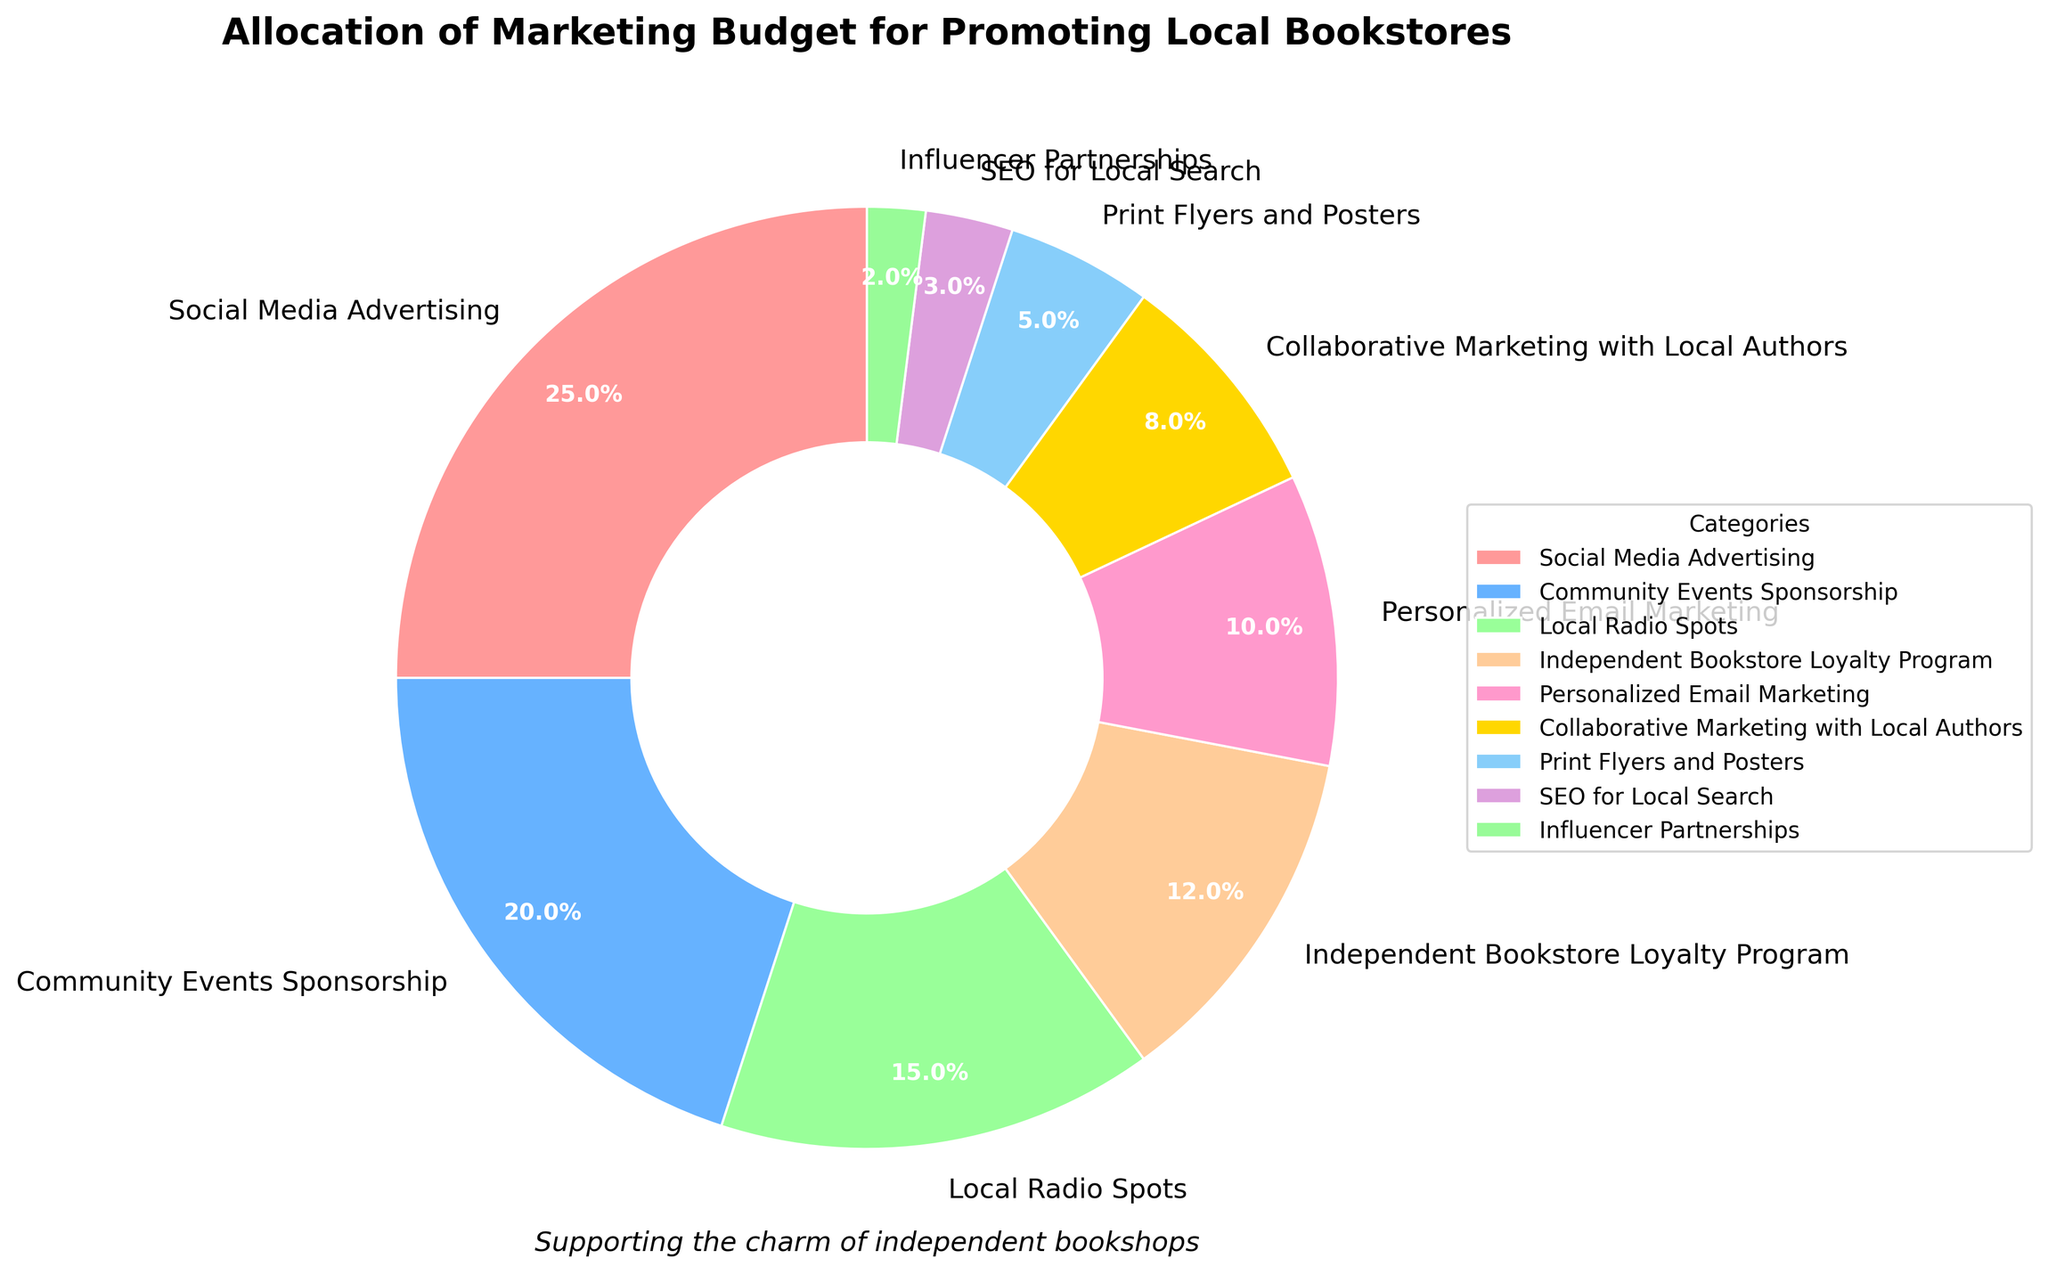What is the category with the highest percentage in the marketing budget? The category with the highest percentage is Social Media Advertising which is allocated 25% of the marketing budget.
Answer: Social Media Advertising What is the combined percentage of Community Events Sponsorship and Local Radio Spots? Add the percentages of Community Events Sponsorship (20%) and Local Radio Spots (15%): 20% + 15% = 35%.
Answer: 35% Which category has a smaller allocation than Independent Bookstore Loyalty Program but larger than SEO for Local Search? Independent Bookstore Loyalty Program has 12% and SEO for Local Search has 3%. The category with an allocation between 3% and 12% is Personalized Email Marketing with 10%.
Answer: Personalized Email Marketing What is the percent difference between Social Media Advertising and the lowest allocated category? Social Media Advertising has 25%, and Influencer Partnerships has the lowest percentage at 2%. The percent difference is 25% - 2% = 23%.
Answer: 23% What is the average percentage allocated to Collaborative Marketing with Local Authors, Print Flyers and Posters, and Influencer Partnerships? Add the percentages: 8% (Collaborative Marketing) + 5% (Print Flyers) + 2% (Influencer Partnerships) = 15%. Then, divide by 3: 15% / 3 = 5%.
Answer: 5% Which categories together make up exactly 50% of the budget? Add Community Events Sponsorship (20%), Local Radio Spots (15%), and Independent Bookstore Loyalty Program (12%): 20% + 15% + 12% = 47% (not enough). Add Local Radio Spots (15%), Independent Bookstore Loyalty Program (12%), and Personalized Email Marketing (10%): 15% + 12% + 10% = 37% (not enough). Add Personalized Email Marketing (10%), Collaborative Marketing with Local Authors (8%), and Print Flyers and Posters (5%): 10% + 8% + 5% = 23% (not enough). There is no combination that adds up to exactly 50%.
Answer: None Which categories have been allocated more than 20%? Only Social Media Advertising with 25% has been allocated more than 20%.
Answer: Social Media Advertising How much more (in percentage) is allocated to Social Media Advertising compared to Collaborative Marketing with Local Authors? Social Media Advertising is allocated 25% and Collaborative Marketing with Local Authors is allocated 8%. The difference is 25% - 8% = 17%.
Answer: 17% What is the total percentage allocated to all categories that promote local entities/individuals (Community Events Sponsorship and Collaborative Marketing with Local Authors)? Add the percentages of Community Events Sponsorship (20%) and Collaborative Marketing with Local Authors (8%): 20% + 8% = 28%.
Answer: 28% Which categories have less than 5% allocation? The category with less than 5% allocation is Influencer Partnerships with 2%.
Answer: Influencer Partnerships 